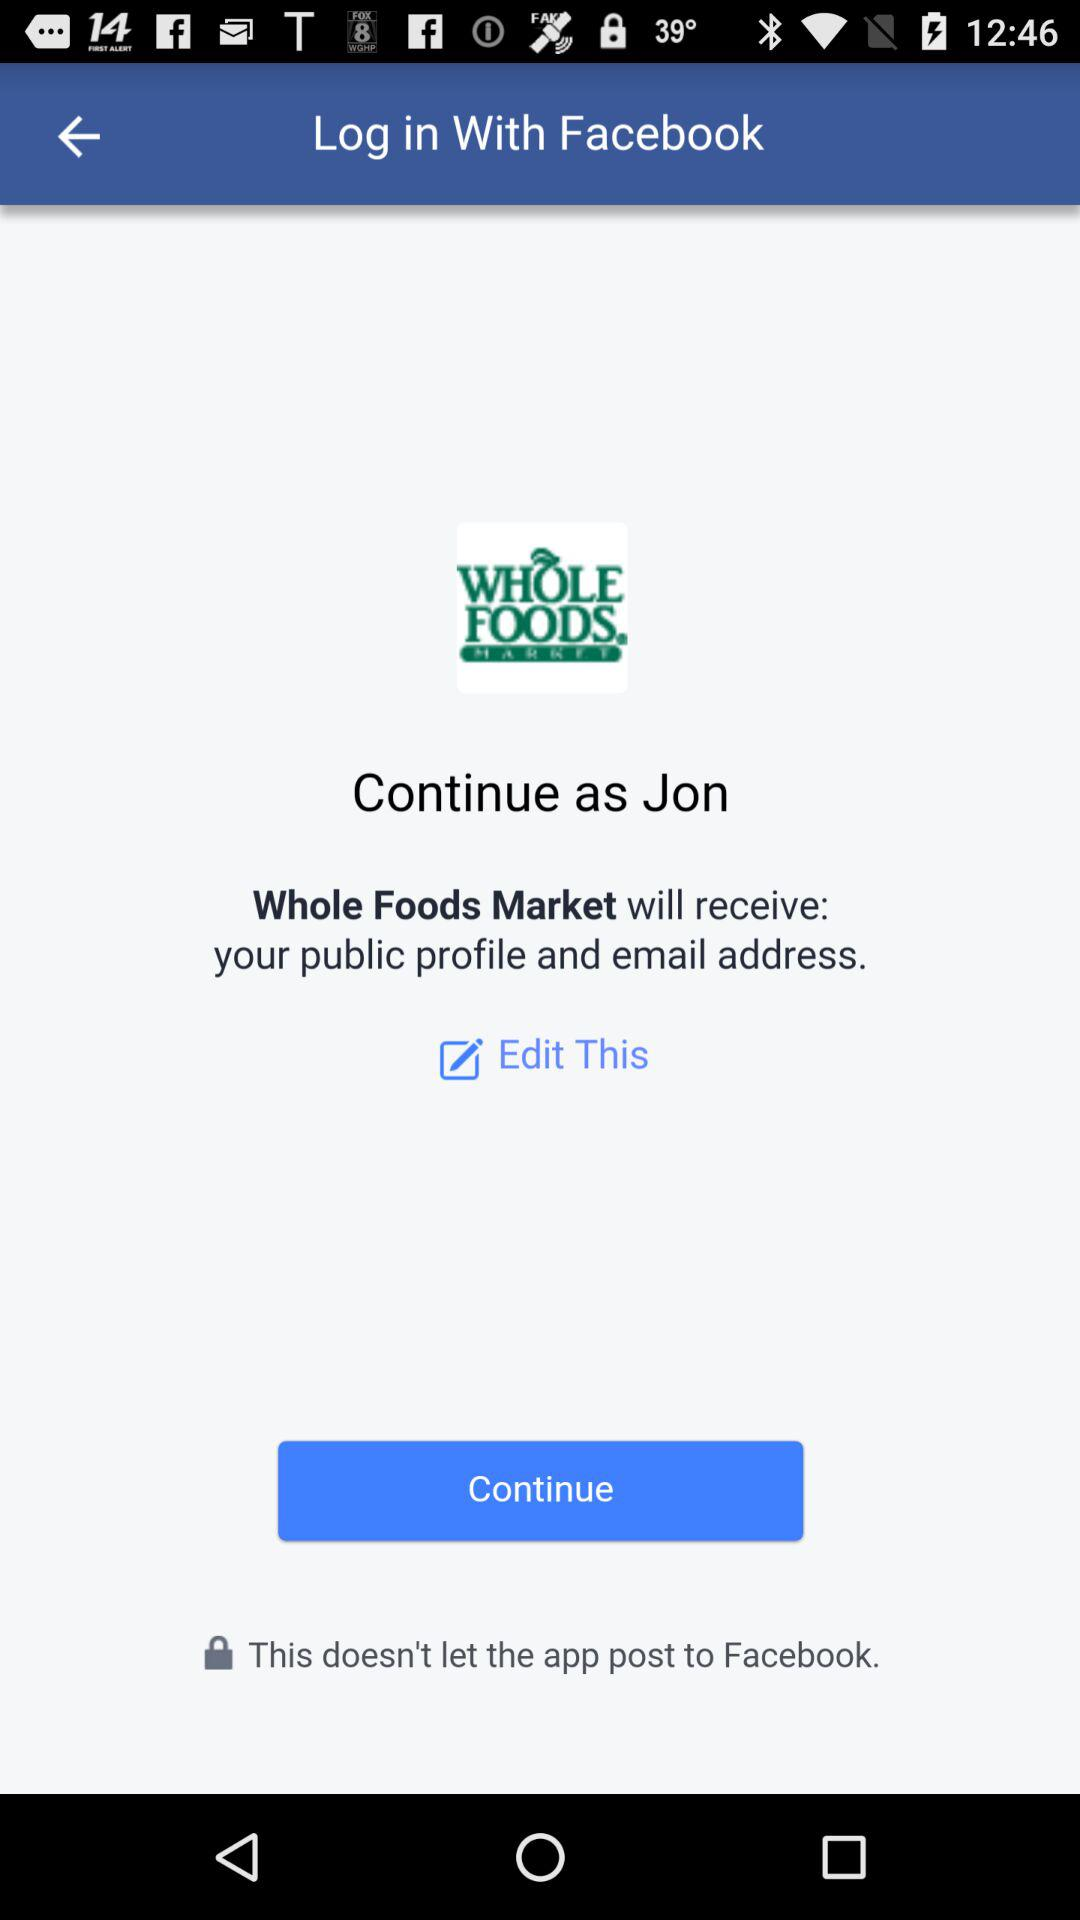What is the user name? The user name is Jon. 